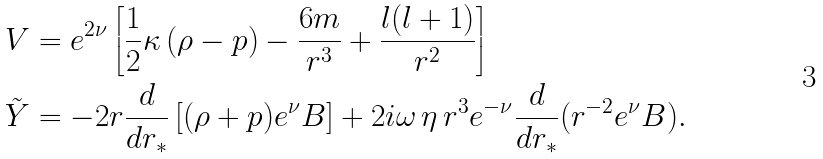Convert formula to latex. <formula><loc_0><loc_0><loc_500><loc_500>V & = e ^ { 2 \nu } \left [ { \frac { 1 } { 2 } } \kappa \, ( \rho - p ) - \frac { 6 m } { r ^ { 3 } } + \frac { l ( l + 1 ) } { r ^ { 2 } } \right ] \\ \tilde { Y } & = - 2 r \frac { d } { d r _ { * } } \left [ ( \rho + p ) e ^ { \nu } B \right ] + 2 i \omega \, \eta \, r ^ { 3 } e ^ { - \nu } \frac { d } { d r _ { * } } ( r ^ { - 2 } e ^ { \nu } B ) .</formula> 